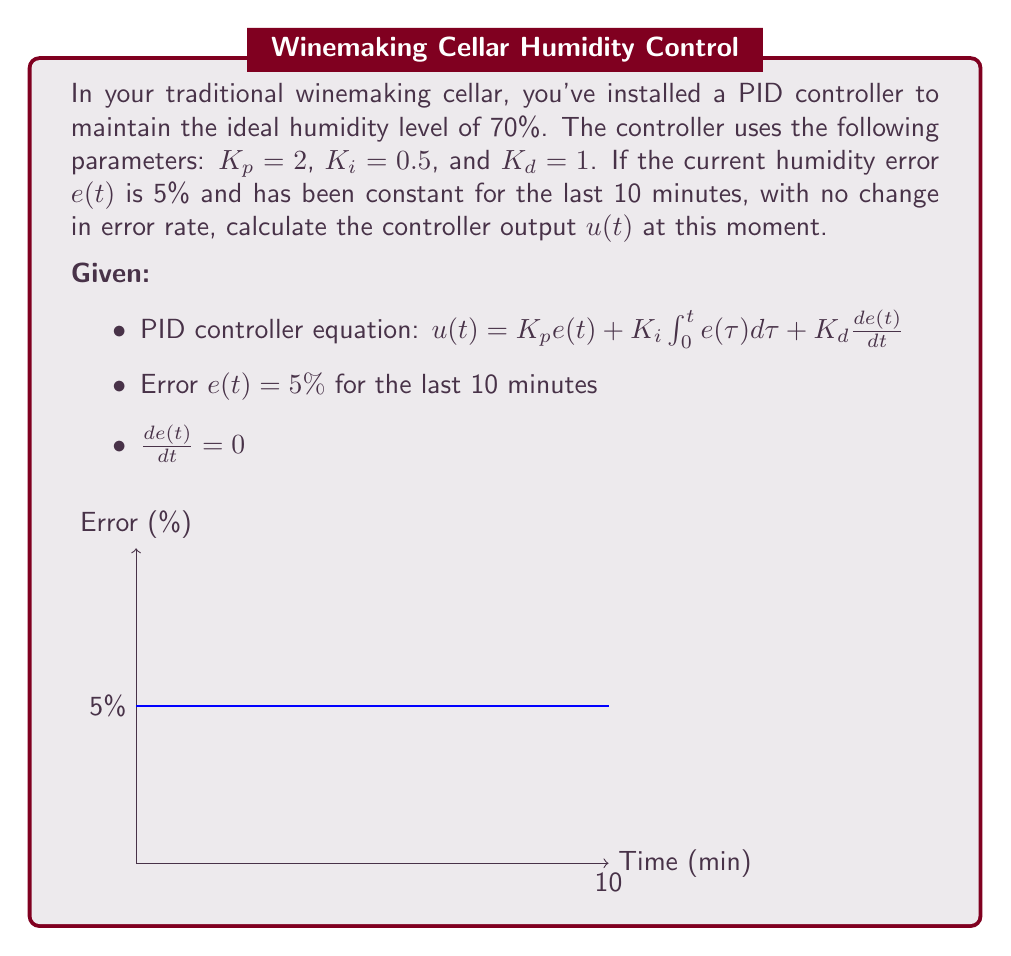Help me with this question. Let's break down the PID controller equation and solve it step by step:

1) The PID controller equation is:
   $u(t) = K_p e(t) + K_i \int_0^t e(\tau) d\tau + K_d \frac{de(t)}{dt}$

2) Given values:
   $K_p = 2$, $K_i = 0.5$, $K_d = 1$
   $e(t) = 5\%$ (constant for 10 minutes)
   $\frac{de(t)}{dt} = 0$ (no change in error rate)

3) Calculate the proportional term:
   $K_p e(t) = 2 \cdot 5\% = 10\%$

4) Calculate the integral term:
   The error has been constant at 5% for 10 minutes, so:
   $K_i \int_0^t e(\tau) d\tau = 0.5 \cdot 5\% \cdot 10\text{ min} = 25\%\text{ min}$

5) Calculate the derivative term:
   Since $\frac{de(t)}{dt} = 0$, this term is zero:
   $K_d \frac{de(t)}{dt} = 1 \cdot 0 = 0$

6) Sum up all terms:
   $u(t) = 10\% + 25\%\text{ min} + 0 = 35\%\text{ min}$
Answer: $35\%\text{ min}$ 